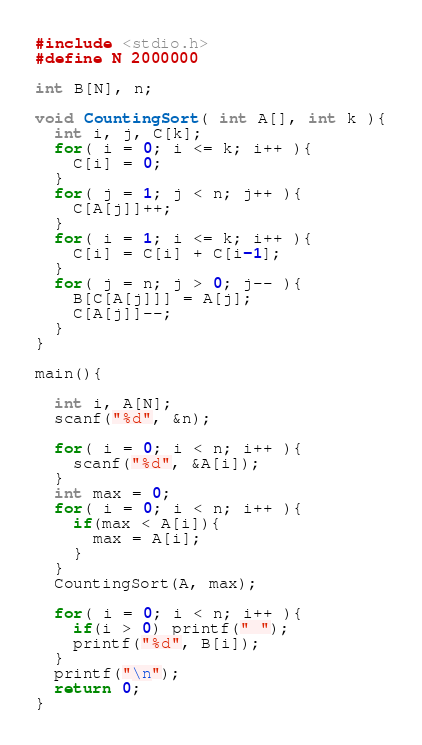Convert code to text. <code><loc_0><loc_0><loc_500><loc_500><_C_>#include <stdio.h>
#define N 2000000

int B[N], n;

void CountingSort( int A[], int k ){
  int i, j, C[k];
  for( i = 0; i <= k; i++ ){
    C[i] = 0;
  }
  for( j = 1; j < n; j++ ){
    C[A[j]]++;
  }
  for( i = 1; i <= k; i++ ){
    C[i] = C[i] + C[i-1];
  }
  for( j = n; j > 0; j-- ){
    B[C[A[j]]] = A[j];
    C[A[j]]--;
  }
}

main(){

  int i, A[N];
  scanf("%d", &n);

  for( i = 0; i < n; i++ ){
    scanf("%d", &A[i]);
  }
  int max = 0;
  for( i = 0; i < n; i++ ){
    if(max < A[i]){
      max = A[i];
    }
  }
  CountingSort(A, max);
  
  for( i = 0; i < n; i++ ){
    if(i > 0) printf(" ");
    printf("%d", B[i]);
  }
  printf("\n");
  return 0;
}</code> 